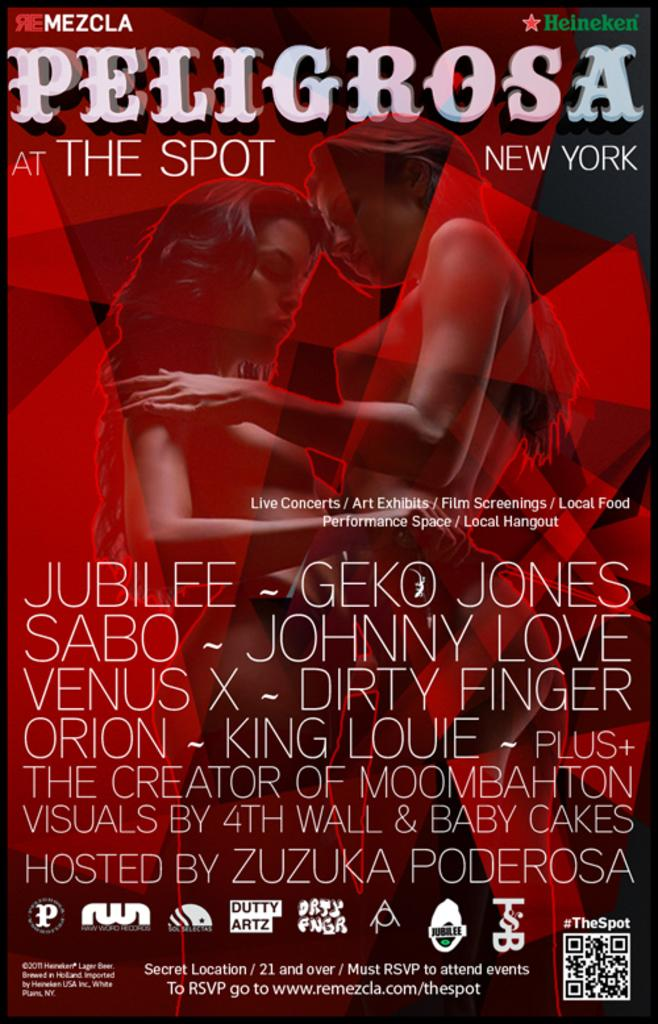<image>
Offer a succinct explanation of the picture presented. A red poster for the show Peligrosa The Spot New York. 